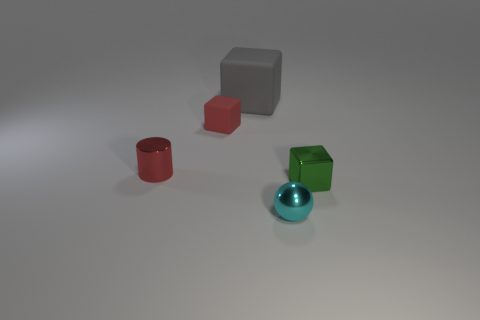Add 3 tiny green cubes. How many objects exist? 8 Subtract all large cubes. How many cubes are left? 2 Subtract all cubes. How many objects are left? 2 Subtract all red blocks. How many blocks are left? 2 Subtract 1 cyan spheres. How many objects are left? 4 Subtract 1 balls. How many balls are left? 0 Subtract all cyan cubes. Subtract all purple spheres. How many cubes are left? 3 Subtract all green balls. How many green cylinders are left? 0 Subtract all small brown objects. Subtract all gray blocks. How many objects are left? 4 Add 3 cyan shiny objects. How many cyan shiny objects are left? 4 